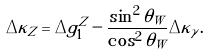Convert formula to latex. <formula><loc_0><loc_0><loc_500><loc_500>\Delta \kappa _ { Z } = \Delta g _ { 1 } ^ { Z } - \frac { \sin ^ { 2 } \theta _ { W } } { \cos ^ { 2 } \theta _ { W } } \Delta \kappa _ { \gamma } .</formula> 